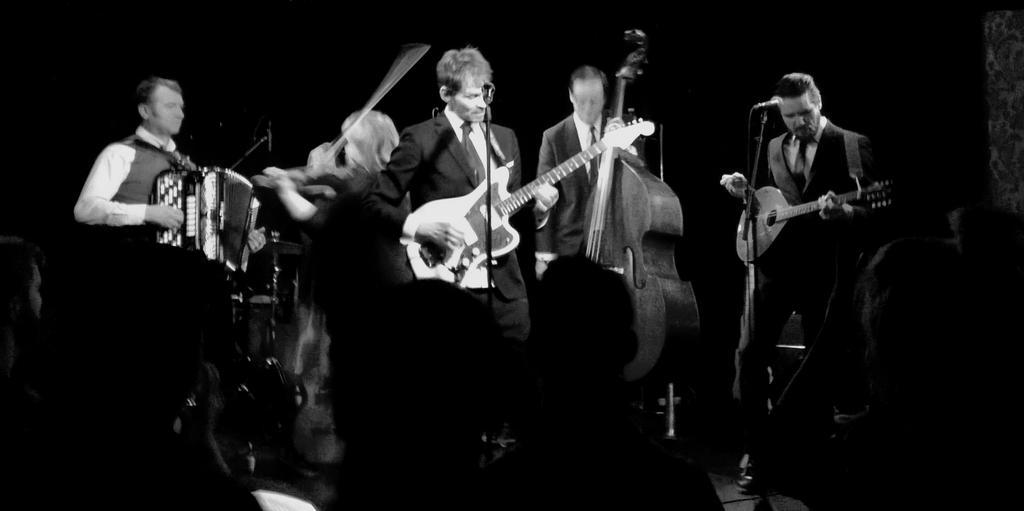Describe this image in one or two sentences. In this image I can see number of people are standing and holding musical instruments. I can also see few mics over here. Here I can see few more people. 